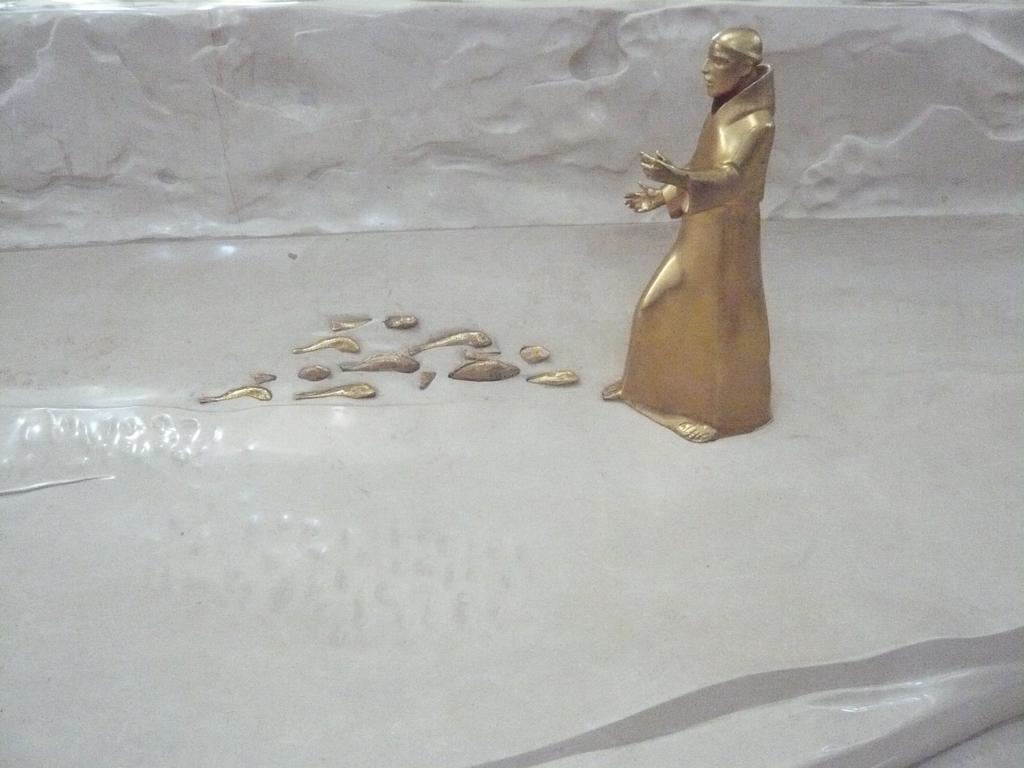In one or two sentences, can you explain what this image depicts? In this image there is a person's metal sculpture. 